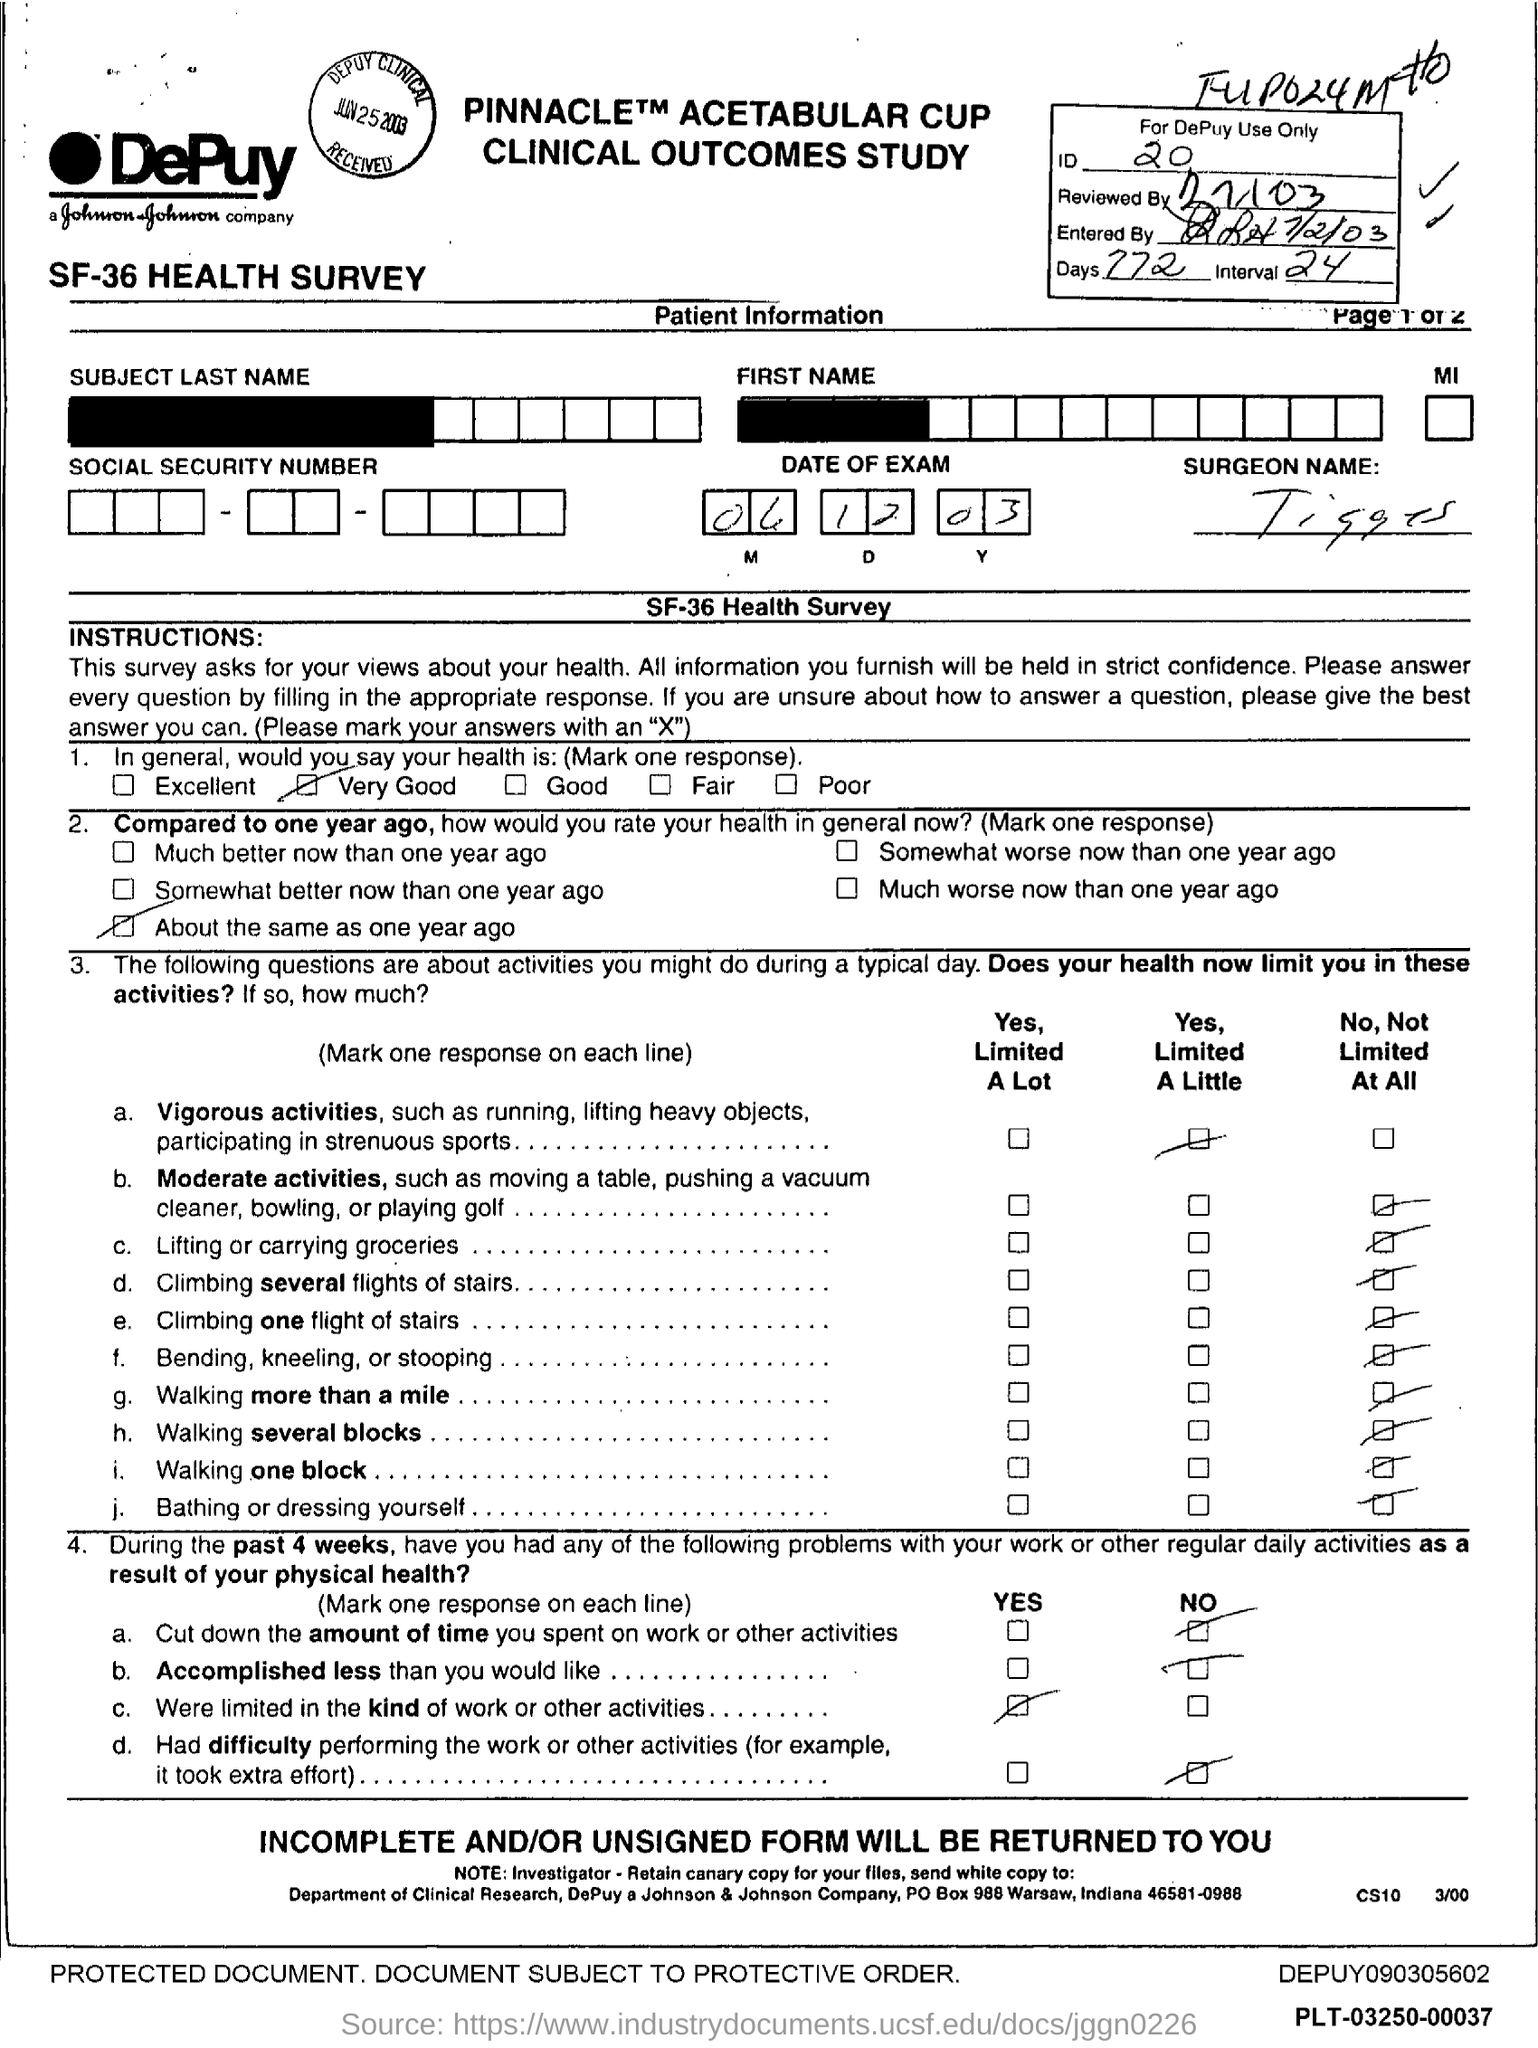How many days?
Your response must be concise. 772. What is the Interval?
Keep it short and to the point. 24. 